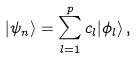Convert formula to latex. <formula><loc_0><loc_0><loc_500><loc_500>| \psi _ { n } \rangle = \sum _ { l = 1 } ^ { p } c _ { l } | \phi _ { l } \rangle \, ,</formula> 